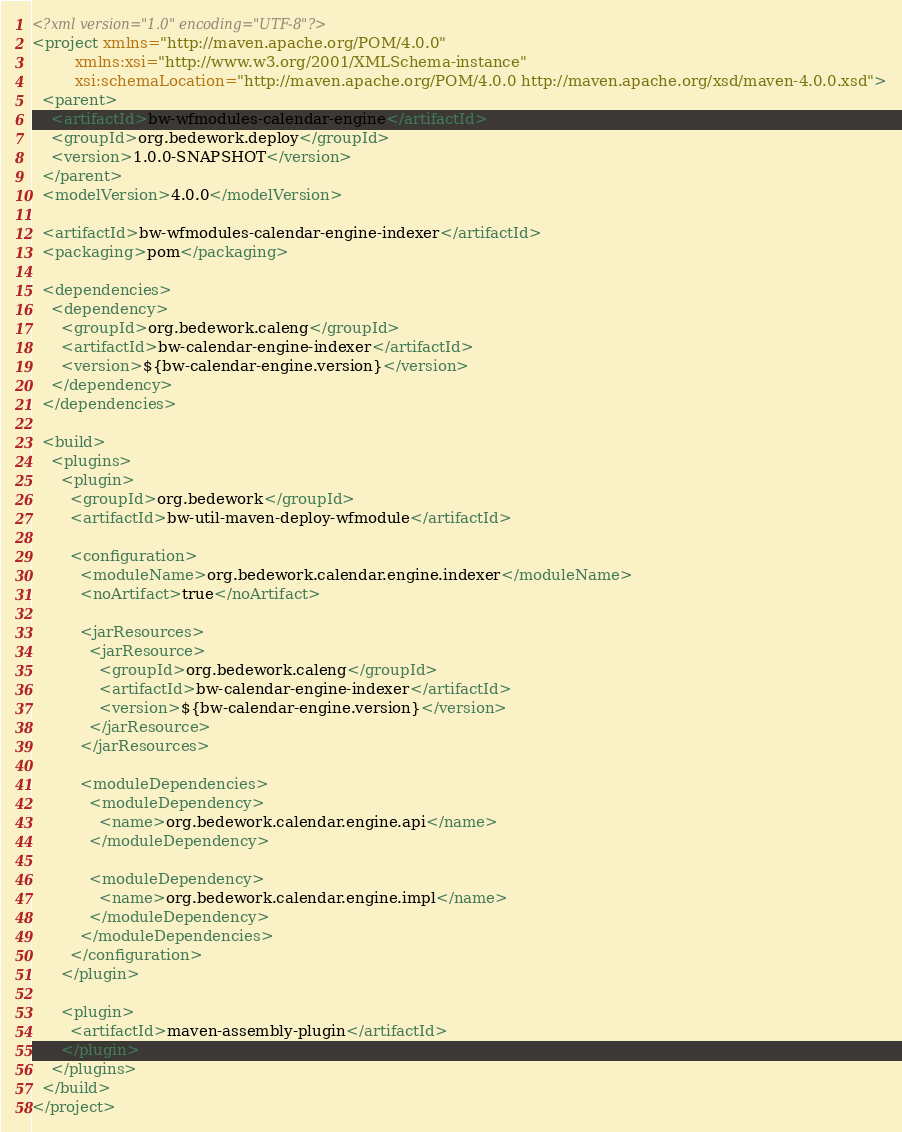Convert code to text. <code><loc_0><loc_0><loc_500><loc_500><_XML_><?xml version="1.0" encoding="UTF-8"?>
<project xmlns="http://maven.apache.org/POM/4.0.0"
         xmlns:xsi="http://www.w3.org/2001/XMLSchema-instance"
         xsi:schemaLocation="http://maven.apache.org/POM/4.0.0 http://maven.apache.org/xsd/maven-4.0.0.xsd">
  <parent>
    <artifactId>bw-wfmodules-calendar-engine</artifactId>
    <groupId>org.bedework.deploy</groupId>
    <version>1.0.0-SNAPSHOT</version>
  </parent>
  <modelVersion>4.0.0</modelVersion>

  <artifactId>bw-wfmodules-calendar-engine-indexer</artifactId>
  <packaging>pom</packaging>

  <dependencies>
    <dependency>
      <groupId>org.bedework.caleng</groupId>
      <artifactId>bw-calendar-engine-indexer</artifactId>
      <version>${bw-calendar-engine.version}</version>
    </dependency>
  </dependencies>

  <build>
    <plugins>
      <plugin>
        <groupId>org.bedework</groupId>
        <artifactId>bw-util-maven-deploy-wfmodule</artifactId>

        <configuration>
          <moduleName>org.bedework.calendar.engine.indexer</moduleName>
          <noArtifact>true</noArtifact>

          <jarResources>
            <jarResource>
              <groupId>org.bedework.caleng</groupId>
              <artifactId>bw-calendar-engine-indexer</artifactId>
              <version>${bw-calendar-engine.version}</version>
            </jarResource>
          </jarResources>

          <moduleDependencies>
            <moduleDependency>
              <name>org.bedework.calendar.engine.api</name>
            </moduleDependency>

            <moduleDependency>
              <name>org.bedework.calendar.engine.impl</name>
            </moduleDependency>
          </moduleDependencies>
        </configuration>
      </plugin>

      <plugin>
        <artifactId>maven-assembly-plugin</artifactId>
      </plugin>
    </plugins>
  </build>
</project></code> 